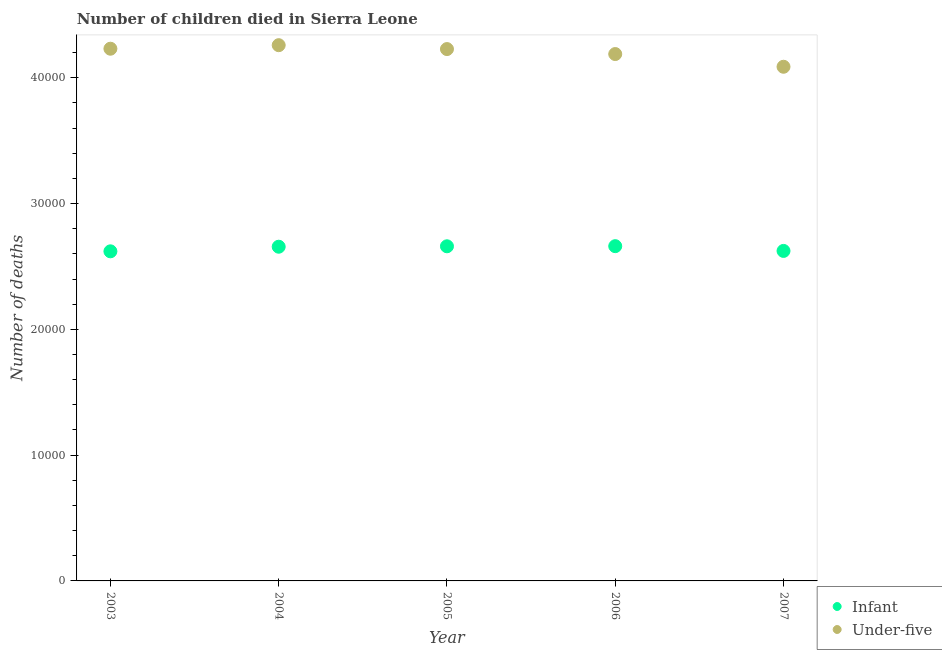How many different coloured dotlines are there?
Provide a short and direct response. 2. Is the number of dotlines equal to the number of legend labels?
Your response must be concise. Yes. What is the number of infant deaths in 2004?
Offer a terse response. 2.66e+04. Across all years, what is the maximum number of under-five deaths?
Your answer should be very brief. 4.26e+04. Across all years, what is the minimum number of under-five deaths?
Provide a succinct answer. 4.09e+04. In which year was the number of under-five deaths maximum?
Your response must be concise. 2004. What is the total number of under-five deaths in the graph?
Offer a very short reply. 2.10e+05. What is the difference between the number of under-five deaths in 2004 and that in 2005?
Make the answer very short. 309. What is the difference between the number of infant deaths in 2007 and the number of under-five deaths in 2004?
Provide a short and direct response. -1.64e+04. What is the average number of under-five deaths per year?
Keep it short and to the point. 4.20e+04. In the year 2006, what is the difference between the number of under-five deaths and number of infant deaths?
Make the answer very short. 1.53e+04. What is the ratio of the number of infant deaths in 2005 to that in 2007?
Ensure brevity in your answer.  1.01. Is the number of under-five deaths in 2005 less than that in 2006?
Your response must be concise. No. What is the difference between the highest and the second highest number of infant deaths?
Give a very brief answer. 10. What is the difference between the highest and the lowest number of infant deaths?
Provide a short and direct response. 410. In how many years, is the number of infant deaths greater than the average number of infant deaths taken over all years?
Your answer should be compact. 3. Is the sum of the number of infant deaths in 2005 and 2007 greater than the maximum number of under-five deaths across all years?
Your answer should be compact. Yes. Does the number of infant deaths monotonically increase over the years?
Provide a succinct answer. No. Is the number of infant deaths strictly greater than the number of under-five deaths over the years?
Provide a succinct answer. No. Is the number of infant deaths strictly less than the number of under-five deaths over the years?
Ensure brevity in your answer.  Yes. How many years are there in the graph?
Provide a succinct answer. 5. Are the values on the major ticks of Y-axis written in scientific E-notation?
Offer a very short reply. No. Does the graph contain any zero values?
Keep it short and to the point. No. Does the graph contain grids?
Offer a very short reply. No. Where does the legend appear in the graph?
Give a very brief answer. Bottom right. How many legend labels are there?
Keep it short and to the point. 2. How are the legend labels stacked?
Offer a terse response. Vertical. What is the title of the graph?
Your answer should be very brief. Number of children died in Sierra Leone. What is the label or title of the Y-axis?
Provide a short and direct response. Number of deaths. What is the Number of deaths of Infant in 2003?
Your response must be concise. 2.62e+04. What is the Number of deaths of Under-five in 2003?
Offer a terse response. 4.23e+04. What is the Number of deaths in Infant in 2004?
Make the answer very short. 2.66e+04. What is the Number of deaths of Under-five in 2004?
Make the answer very short. 4.26e+04. What is the Number of deaths in Infant in 2005?
Your answer should be compact. 2.66e+04. What is the Number of deaths of Under-five in 2005?
Your answer should be compact. 4.23e+04. What is the Number of deaths of Infant in 2006?
Your answer should be very brief. 2.66e+04. What is the Number of deaths in Under-five in 2006?
Provide a succinct answer. 4.19e+04. What is the Number of deaths of Infant in 2007?
Ensure brevity in your answer.  2.62e+04. What is the Number of deaths in Under-five in 2007?
Keep it short and to the point. 4.09e+04. Across all years, what is the maximum Number of deaths in Infant?
Provide a short and direct response. 2.66e+04. Across all years, what is the maximum Number of deaths of Under-five?
Make the answer very short. 4.26e+04. Across all years, what is the minimum Number of deaths in Infant?
Keep it short and to the point. 2.62e+04. Across all years, what is the minimum Number of deaths in Under-five?
Keep it short and to the point. 4.09e+04. What is the total Number of deaths of Infant in the graph?
Give a very brief answer. 1.32e+05. What is the total Number of deaths of Under-five in the graph?
Ensure brevity in your answer.  2.10e+05. What is the difference between the Number of deaths of Infant in 2003 and that in 2004?
Offer a very short reply. -366. What is the difference between the Number of deaths of Under-five in 2003 and that in 2004?
Make the answer very short. -281. What is the difference between the Number of deaths of Infant in 2003 and that in 2005?
Keep it short and to the point. -400. What is the difference between the Number of deaths in Infant in 2003 and that in 2006?
Ensure brevity in your answer.  -410. What is the difference between the Number of deaths of Under-five in 2003 and that in 2006?
Your answer should be very brief. 424. What is the difference between the Number of deaths in Infant in 2003 and that in 2007?
Give a very brief answer. -32. What is the difference between the Number of deaths in Under-five in 2003 and that in 2007?
Provide a succinct answer. 1435. What is the difference between the Number of deaths of Infant in 2004 and that in 2005?
Your answer should be very brief. -34. What is the difference between the Number of deaths of Under-five in 2004 and that in 2005?
Provide a succinct answer. 309. What is the difference between the Number of deaths of Infant in 2004 and that in 2006?
Your answer should be very brief. -44. What is the difference between the Number of deaths in Under-five in 2004 and that in 2006?
Keep it short and to the point. 705. What is the difference between the Number of deaths in Infant in 2004 and that in 2007?
Make the answer very short. 334. What is the difference between the Number of deaths in Under-five in 2004 and that in 2007?
Offer a very short reply. 1716. What is the difference between the Number of deaths in Infant in 2005 and that in 2006?
Provide a short and direct response. -10. What is the difference between the Number of deaths in Under-five in 2005 and that in 2006?
Offer a terse response. 396. What is the difference between the Number of deaths in Infant in 2005 and that in 2007?
Offer a terse response. 368. What is the difference between the Number of deaths in Under-five in 2005 and that in 2007?
Offer a terse response. 1407. What is the difference between the Number of deaths of Infant in 2006 and that in 2007?
Your answer should be very brief. 378. What is the difference between the Number of deaths of Under-five in 2006 and that in 2007?
Give a very brief answer. 1011. What is the difference between the Number of deaths of Infant in 2003 and the Number of deaths of Under-five in 2004?
Offer a very short reply. -1.64e+04. What is the difference between the Number of deaths of Infant in 2003 and the Number of deaths of Under-five in 2005?
Make the answer very short. -1.61e+04. What is the difference between the Number of deaths in Infant in 2003 and the Number of deaths in Under-five in 2006?
Your answer should be very brief. -1.57e+04. What is the difference between the Number of deaths of Infant in 2003 and the Number of deaths of Under-five in 2007?
Ensure brevity in your answer.  -1.47e+04. What is the difference between the Number of deaths of Infant in 2004 and the Number of deaths of Under-five in 2005?
Offer a very short reply. -1.57e+04. What is the difference between the Number of deaths of Infant in 2004 and the Number of deaths of Under-five in 2006?
Make the answer very short. -1.53e+04. What is the difference between the Number of deaths of Infant in 2004 and the Number of deaths of Under-five in 2007?
Offer a very short reply. -1.43e+04. What is the difference between the Number of deaths in Infant in 2005 and the Number of deaths in Under-five in 2006?
Make the answer very short. -1.53e+04. What is the difference between the Number of deaths of Infant in 2005 and the Number of deaths of Under-five in 2007?
Ensure brevity in your answer.  -1.43e+04. What is the difference between the Number of deaths in Infant in 2006 and the Number of deaths in Under-five in 2007?
Give a very brief answer. -1.43e+04. What is the average Number of deaths in Infant per year?
Offer a terse response. 2.64e+04. What is the average Number of deaths in Under-five per year?
Your response must be concise. 4.20e+04. In the year 2003, what is the difference between the Number of deaths in Infant and Number of deaths in Under-five?
Your answer should be very brief. -1.61e+04. In the year 2004, what is the difference between the Number of deaths of Infant and Number of deaths of Under-five?
Your answer should be compact. -1.60e+04. In the year 2005, what is the difference between the Number of deaths in Infant and Number of deaths in Under-five?
Give a very brief answer. -1.57e+04. In the year 2006, what is the difference between the Number of deaths of Infant and Number of deaths of Under-five?
Ensure brevity in your answer.  -1.53e+04. In the year 2007, what is the difference between the Number of deaths in Infant and Number of deaths in Under-five?
Your answer should be compact. -1.46e+04. What is the ratio of the Number of deaths in Infant in 2003 to that in 2004?
Provide a short and direct response. 0.99. What is the ratio of the Number of deaths in Infant in 2003 to that in 2005?
Provide a short and direct response. 0.98. What is the ratio of the Number of deaths in Under-five in 2003 to that in 2005?
Your response must be concise. 1. What is the ratio of the Number of deaths of Infant in 2003 to that in 2006?
Give a very brief answer. 0.98. What is the ratio of the Number of deaths in Infant in 2003 to that in 2007?
Provide a succinct answer. 1. What is the ratio of the Number of deaths in Under-five in 2003 to that in 2007?
Offer a very short reply. 1.04. What is the ratio of the Number of deaths in Infant in 2004 to that in 2005?
Your answer should be very brief. 1. What is the ratio of the Number of deaths of Under-five in 2004 to that in 2005?
Offer a very short reply. 1.01. What is the ratio of the Number of deaths in Infant in 2004 to that in 2006?
Make the answer very short. 1. What is the ratio of the Number of deaths of Under-five in 2004 to that in 2006?
Give a very brief answer. 1.02. What is the ratio of the Number of deaths of Infant in 2004 to that in 2007?
Ensure brevity in your answer.  1.01. What is the ratio of the Number of deaths in Under-five in 2004 to that in 2007?
Make the answer very short. 1.04. What is the ratio of the Number of deaths in Under-five in 2005 to that in 2006?
Offer a very short reply. 1.01. What is the ratio of the Number of deaths in Infant in 2005 to that in 2007?
Provide a short and direct response. 1.01. What is the ratio of the Number of deaths of Under-five in 2005 to that in 2007?
Offer a terse response. 1.03. What is the ratio of the Number of deaths in Infant in 2006 to that in 2007?
Your answer should be very brief. 1.01. What is the ratio of the Number of deaths of Under-five in 2006 to that in 2007?
Your response must be concise. 1.02. What is the difference between the highest and the second highest Number of deaths in Infant?
Give a very brief answer. 10. What is the difference between the highest and the second highest Number of deaths in Under-five?
Your response must be concise. 281. What is the difference between the highest and the lowest Number of deaths of Infant?
Offer a terse response. 410. What is the difference between the highest and the lowest Number of deaths of Under-five?
Your response must be concise. 1716. 